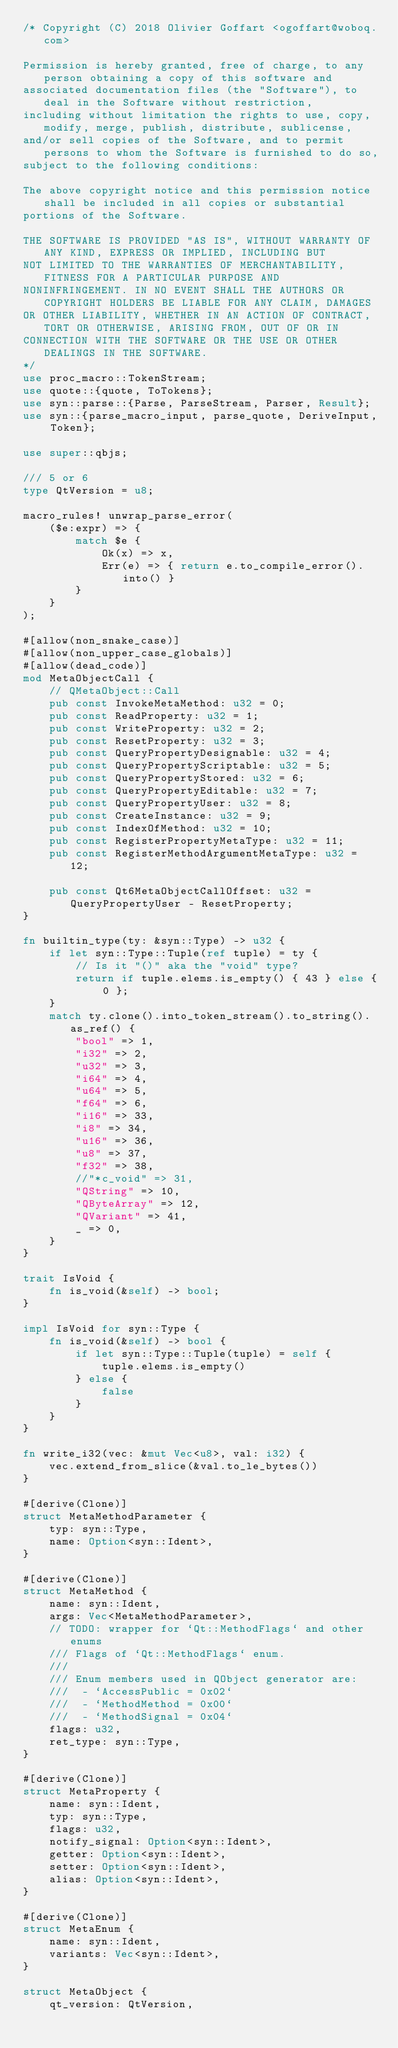Convert code to text. <code><loc_0><loc_0><loc_500><loc_500><_Rust_>/* Copyright (C) 2018 Olivier Goffart <ogoffart@woboq.com>

Permission is hereby granted, free of charge, to any person obtaining a copy of this software and
associated documentation files (the "Software"), to deal in the Software without restriction,
including without limitation the rights to use, copy, modify, merge, publish, distribute, sublicense,
and/or sell copies of the Software, and to permit persons to whom the Software is furnished to do so,
subject to the following conditions:

The above copyright notice and this permission notice shall be included in all copies or substantial
portions of the Software.

THE SOFTWARE IS PROVIDED "AS IS", WITHOUT WARRANTY OF ANY KIND, EXPRESS OR IMPLIED, INCLUDING BUT
NOT LIMITED TO THE WARRANTIES OF MERCHANTABILITY, FITNESS FOR A PARTICULAR PURPOSE AND
NONINFRINGEMENT. IN NO EVENT SHALL THE AUTHORS OR COPYRIGHT HOLDERS BE LIABLE FOR ANY CLAIM, DAMAGES
OR OTHER LIABILITY, WHETHER IN AN ACTION OF CONTRACT, TORT OR OTHERWISE, ARISING FROM, OUT OF OR IN
CONNECTION WITH THE SOFTWARE OR THE USE OR OTHER DEALINGS IN THE SOFTWARE.
*/
use proc_macro::TokenStream;
use quote::{quote, ToTokens};
use syn::parse::{Parse, ParseStream, Parser, Result};
use syn::{parse_macro_input, parse_quote, DeriveInput, Token};

use super::qbjs;

/// 5 or 6
type QtVersion = u8;

macro_rules! unwrap_parse_error(
    ($e:expr) => {
        match $e {
            Ok(x) => x,
            Err(e) => { return e.to_compile_error().into() }
        }
    }
);

#[allow(non_snake_case)]
#[allow(non_upper_case_globals)]
#[allow(dead_code)]
mod MetaObjectCall {
    // QMetaObject::Call
    pub const InvokeMetaMethod: u32 = 0;
    pub const ReadProperty: u32 = 1;
    pub const WriteProperty: u32 = 2;
    pub const ResetProperty: u32 = 3;
    pub const QueryPropertyDesignable: u32 = 4;
    pub const QueryPropertyScriptable: u32 = 5;
    pub const QueryPropertyStored: u32 = 6;
    pub const QueryPropertyEditable: u32 = 7;
    pub const QueryPropertyUser: u32 = 8;
    pub const CreateInstance: u32 = 9;
    pub const IndexOfMethod: u32 = 10;
    pub const RegisterPropertyMetaType: u32 = 11;
    pub const RegisterMethodArgumentMetaType: u32 = 12;

    pub const Qt6MetaObjectCallOffset: u32 = QueryPropertyUser - ResetProperty;
}

fn builtin_type(ty: &syn::Type) -> u32 {
    if let syn::Type::Tuple(ref tuple) = ty {
        // Is it "()" aka the "void" type?
        return if tuple.elems.is_empty() { 43 } else { 0 };
    }
    match ty.clone().into_token_stream().to_string().as_ref() {
        "bool" => 1,
        "i32" => 2,
        "u32" => 3,
        "i64" => 4,
        "u64" => 5,
        "f64" => 6,
        "i16" => 33,
        "i8" => 34,
        "u16" => 36,
        "u8" => 37,
        "f32" => 38,
        //"*c_void" => 31,
        "QString" => 10,
        "QByteArray" => 12,
        "QVariant" => 41,
        _ => 0,
    }
}

trait IsVoid {
    fn is_void(&self) -> bool;
}

impl IsVoid for syn::Type {
    fn is_void(&self) -> bool {
        if let syn::Type::Tuple(tuple) = self {
            tuple.elems.is_empty()
        } else {
            false
        }
    }
}

fn write_i32(vec: &mut Vec<u8>, val: i32) {
    vec.extend_from_slice(&val.to_le_bytes())
}

#[derive(Clone)]
struct MetaMethodParameter {
    typ: syn::Type,
    name: Option<syn::Ident>,
}

#[derive(Clone)]
struct MetaMethod {
    name: syn::Ident,
    args: Vec<MetaMethodParameter>,
    // TODO: wrapper for `Qt::MethodFlags` and other enums
    /// Flags of `Qt::MethodFlags` enum.
    ///
    /// Enum members used in QObject generator are:
    ///  - `AccessPublic = 0x02`
    ///  - `MethodMethod = 0x00`
    ///  - `MethodSignal = 0x04`
    flags: u32,
    ret_type: syn::Type,
}

#[derive(Clone)]
struct MetaProperty {
    name: syn::Ident,
    typ: syn::Type,
    flags: u32,
    notify_signal: Option<syn::Ident>,
    getter: Option<syn::Ident>,
    setter: Option<syn::Ident>,
    alias: Option<syn::Ident>,
}

#[derive(Clone)]
struct MetaEnum {
    name: syn::Ident,
    variants: Vec<syn::Ident>,
}

struct MetaObject {
    qt_version: QtVersion,</code> 